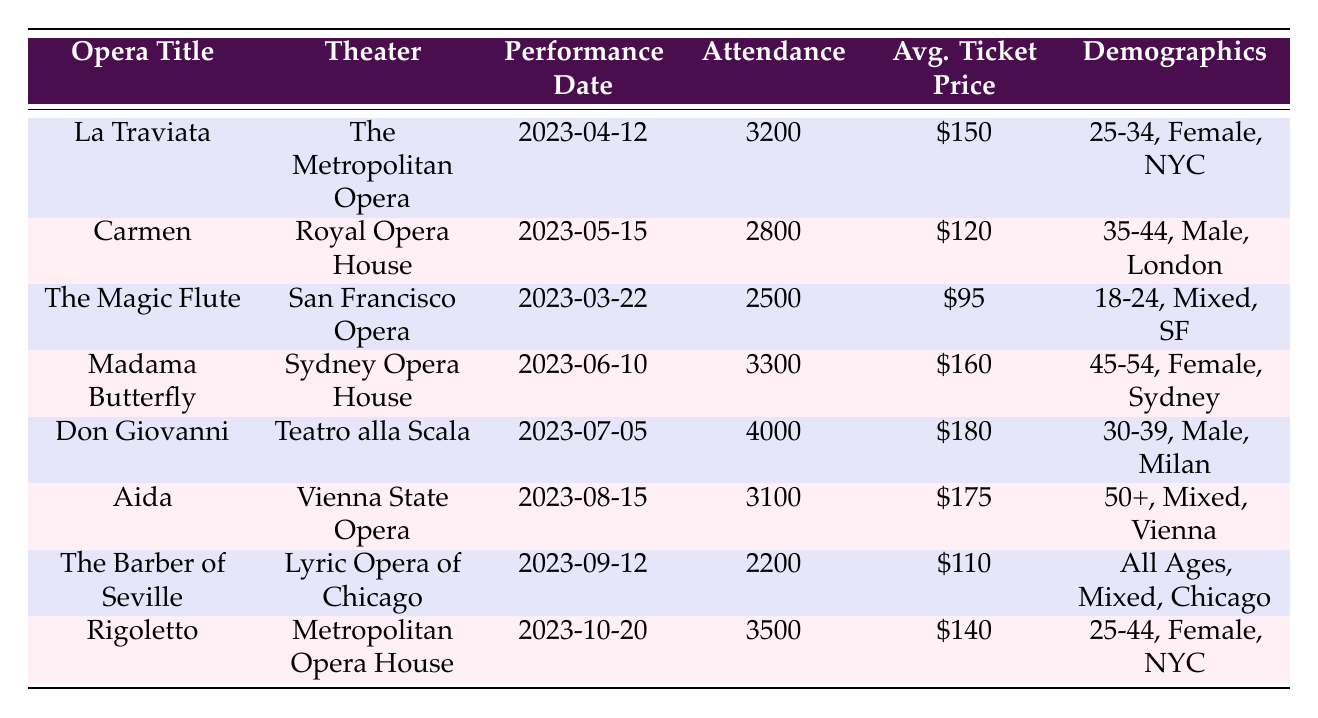What is the attendance for "Don Giovanni"? The table lists the attendance specifically for "Don Giovanni" as 4000.
Answer: 4000 Which opera had the highest average ticket price in 2023? By comparing the average ticket prices, "Don Giovanni" has the highest at $180.
Answer: $180 How many performances had an attendance of over 3000? The table shows three operas with an attendance over 3000: "La Traviata" (3200), "Madama Butterfly" (3300), and "Don Giovanni" (4000). Therefore, there are three performances.
Answer: 3 What is the gender demographic for the "Aida" performance? According to the table, the gender demographic for "Aida" is mixed.
Answer: Mixed What is the total attendance for the opera performances listed? Adding the attendance numbers together: 3200 + 2800 + 2500 + 3300 + 4000 + 3100 + 2200 + 3500 = 22600.
Answer: 22600 Which city hosted the performance of "Carmen"? The table specifies that "Carmen" was performed at the Royal Opera House in London.
Answer: London What is the average attendance across all operas? Calculating the average: Total attendance (22600) divided by the number of performances (8) gives 22600 / 8 = 2825.
Answer: 2825 Is "The Magic Flute" the only opera performed in San Francisco in 2023? Yes, the table indicates that "The Magic Flute" is the only opera listed with San Francisco as its location.
Answer: Yes What age group had the highest attendance for performances? Comparing the attendance, the age group of 30-39 for "Don Giovanni" had the highest attendance of 4000.
Answer: 30-39 